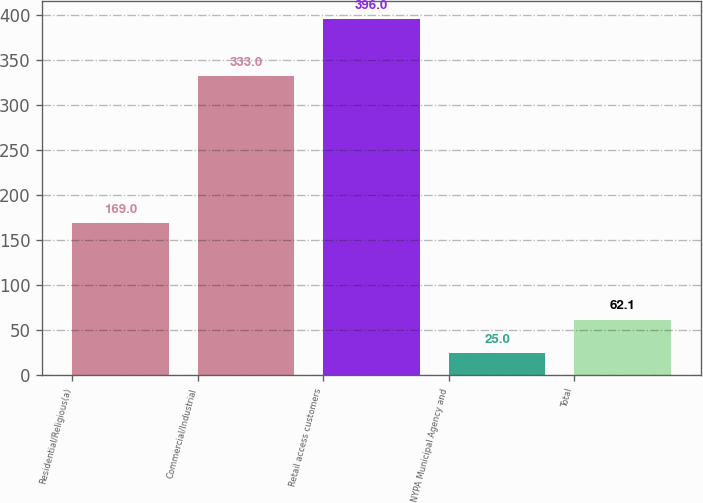Convert chart to OTSL. <chart><loc_0><loc_0><loc_500><loc_500><bar_chart><fcel>Residential/Religious(a)<fcel>Commercial/Industrial<fcel>Retail access customers<fcel>NYPA Municipal Agency and<fcel>Total<nl><fcel>169<fcel>333<fcel>396<fcel>25<fcel>62.1<nl></chart> 